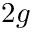<formula> <loc_0><loc_0><loc_500><loc_500>2 g</formula> 